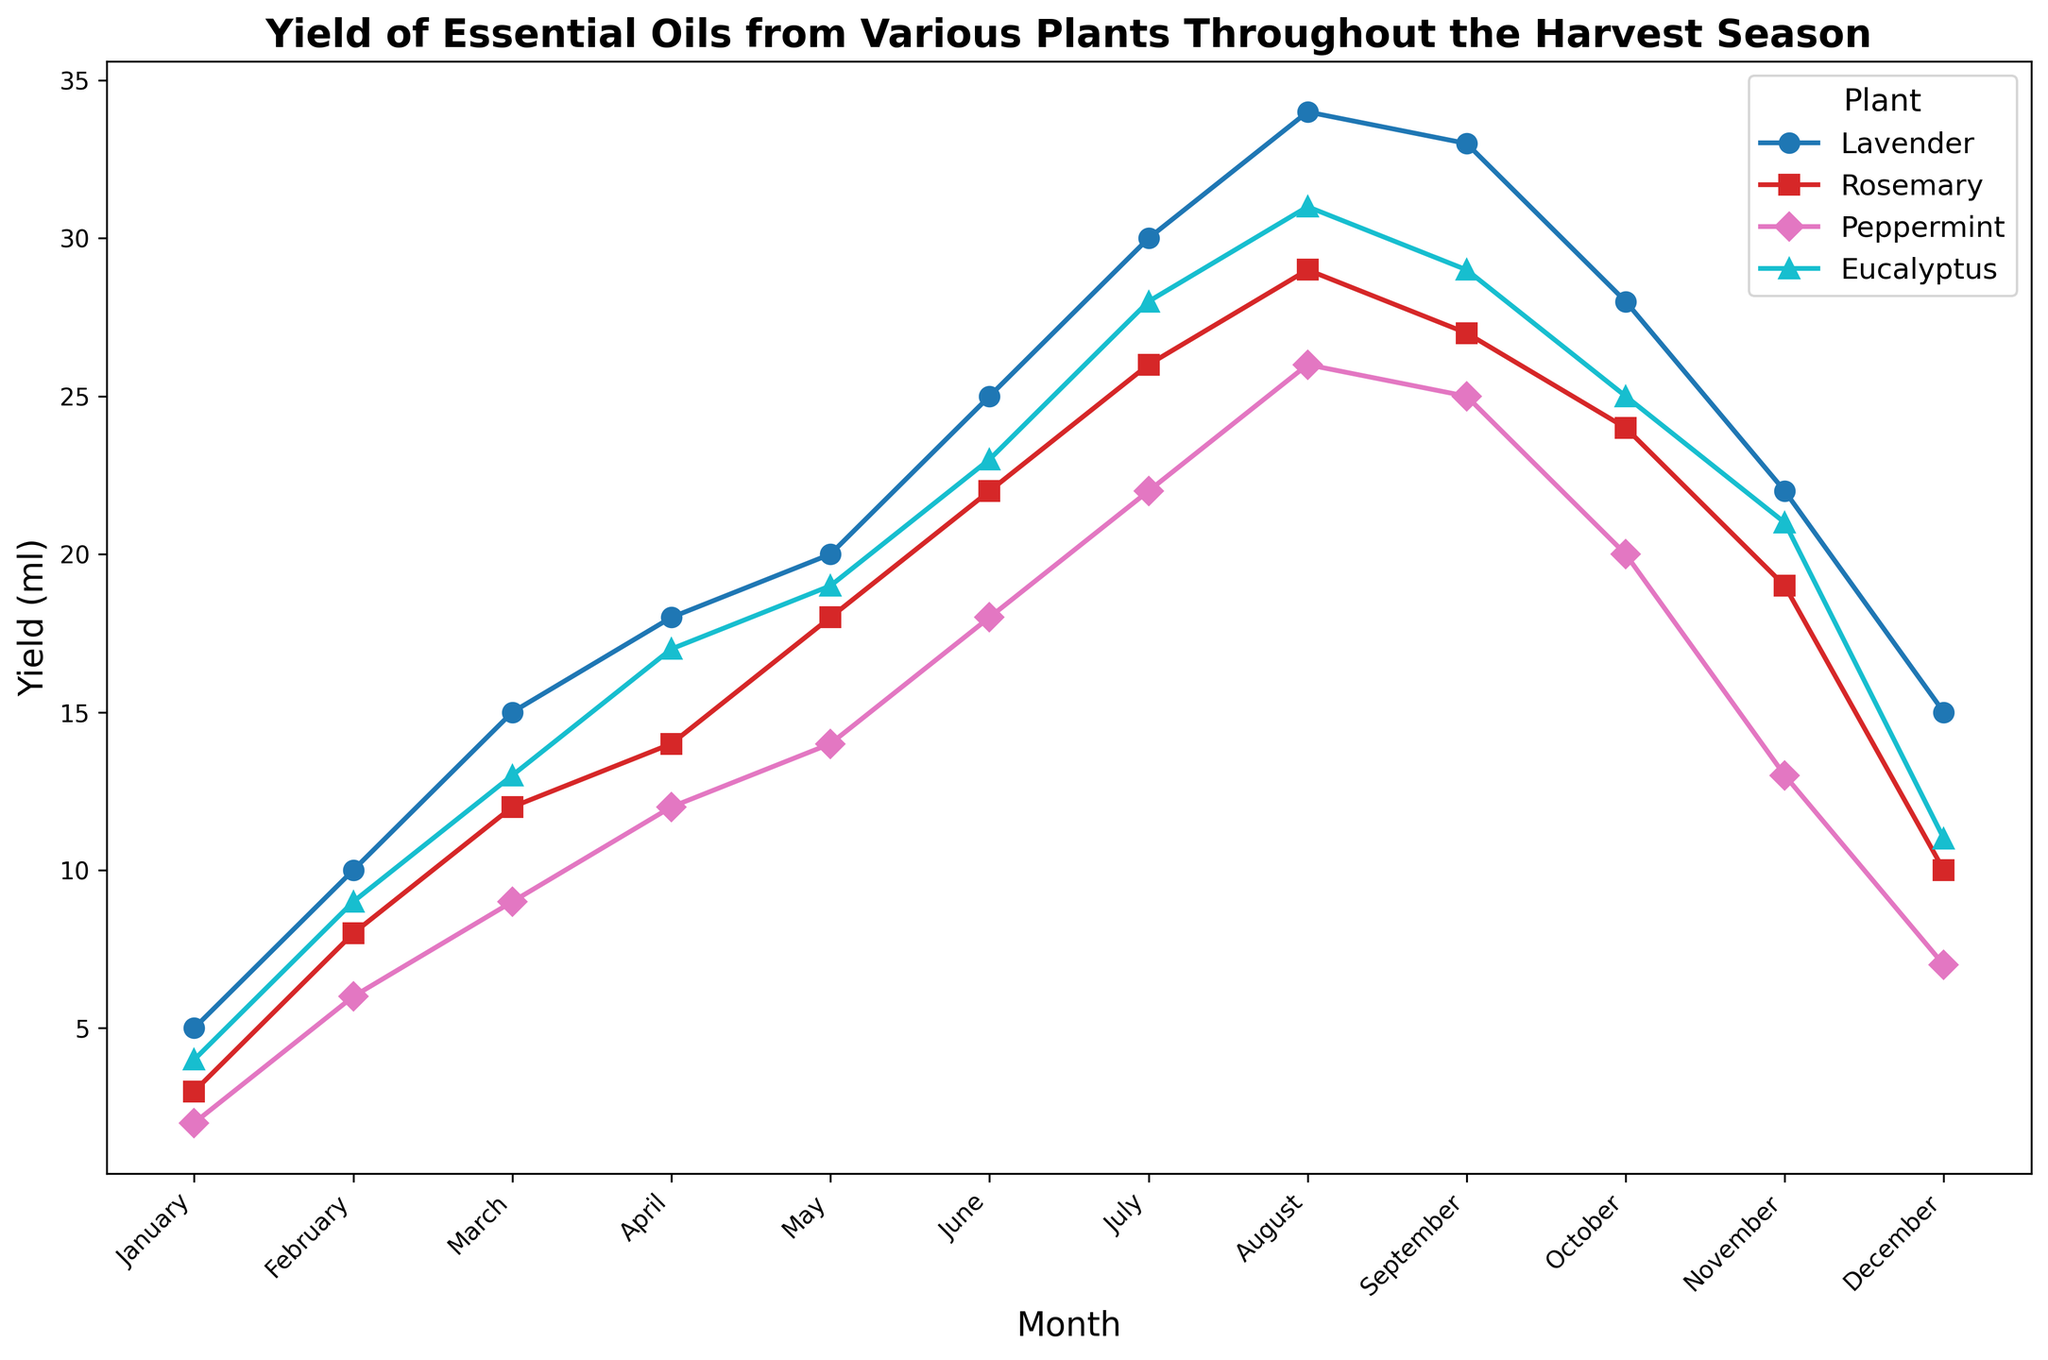Which plant had the highest yield in August? Looking at the data for August, the plant with the highest yield is shown by the peak in the corresponding line. The highest point for August is from the Eucalyptus plant.
Answer: Eucalyptus How much more essential oil does Lavender produce in July compared to January? First, locate the yield of Lavender in January (5 ml) and July (30 ml). Then, subtract the yield of January from the yield in July: 30 ml - 5 ml = 25 ml.
Answer: 25 ml Which month sees the peak yield for Rosemary? Identify the highest point on the Rosemary line, which signifies the maximum yield. The peak yield for Rosemary is in August, where it yields 29 ml.
Answer: August Between February and March, which plant shows the highest increase in yield? Calculate the increase by subtracting February yields from March yields for each plant. Lavender increases by 5 ml, Rosemary by 4 ml, Peppermint by 3 ml, and Eucalyptus by 4 ml. The highest increase is for Lavender.
Answer: Lavender What is the total essential oil yield for Peppermint and Eucalyptus in June? Add the yields of Peppermint (18 ml) and Eucalyptus (23 ml) in June: 18 ml + 23 ml = 41 ml.
Answer: 41 ml During which month do all plants have the lowest yield? Compare the monthly yields across all plants to find the lowest joint yield. In January, all plants have lower yields compared to other months.
Answer: January Which plant has the most stable yield throughout the year? Stability can be inferred from the least fluctuations in the yield line. Comparing line variations, Peppermint's line shows lesser fluctuation compared to others.
Answer: Peppermint How does the yield of Eucalyptus in March compare to Rosemary in April? Locate the yield of Eucalyptus in March (13 ml) and Rosemary in April (14 ml). Eucalyptus in March is 1 ml less than Rosemary in April.
Answer: 1 ml less What is the average yield of Lavender between June and September? Sum yields of Lavender from June (25 ml), July (30 ml), August (34 ml), and September (33 ml): 25 + 30 + 34 + 33 = 122. Then, divide by the number of months (4): 122 / 4 = 30.5 ml.
Answer: 30.5 ml In which month does Peppermint reach its highest yield, and what is that yield? Identify the peak point on the Peppermint line. The highest yield is in August at 26 ml.
Answer: August, 26 ml 